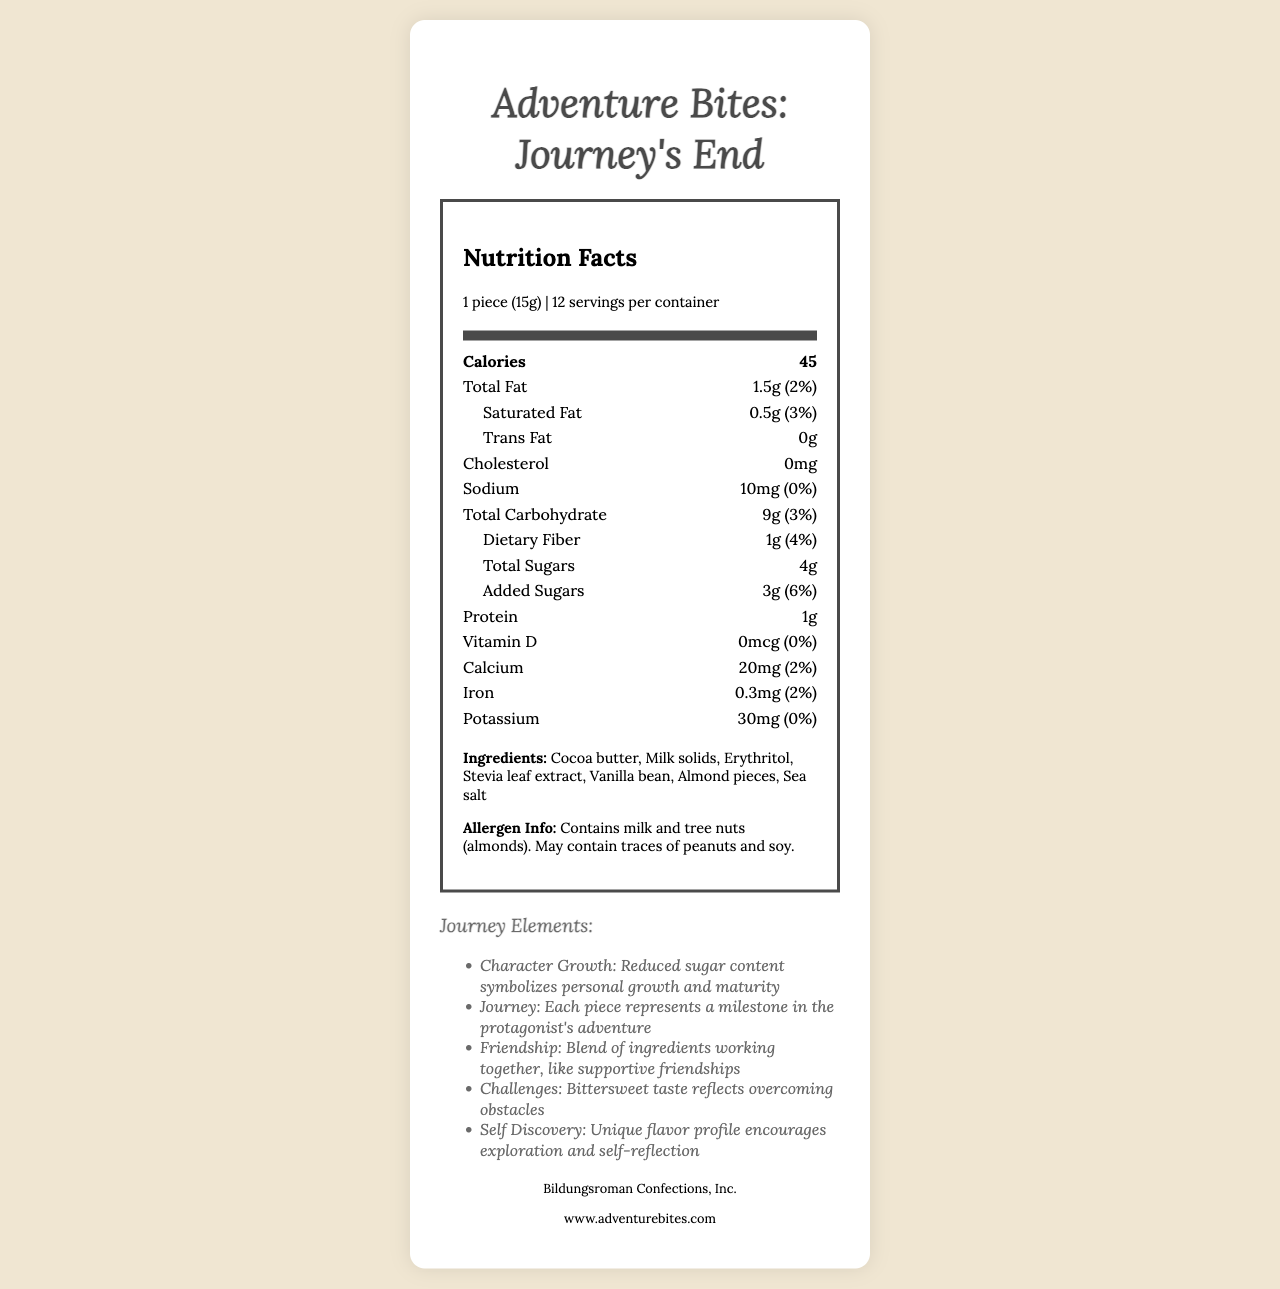what is the product name? The product name is displayed at the top of the document.
Answer: Adventure Bites: Journey's End how many calories are there per serving? The calories per serving are listed directly under "Nutrition Facts".
Answer: 45 what are the total sugars in one piece of candy? The total sugars are indicated in the "Total Sugars" section of the nutrition label.
Answer: 4g what is the amount of total fat in one serving? The amount of total fat is specified in the "Total Fat" section of the nutrition label.
Answer: 1.5g what allergens are present in the candy? This information is found in the allergen info section at the bottom of the document.
Answer: Milk and tree nuts (almonds) which nutrient has the highest daily value percentage in one serving? A. Sodium B. Saturated Fat C. Dietary Fiber D. Added Sugars Added sugars have the highest daily value percentage at 6%.
Answer: D. Added Sugars what does the reduced sugar content symbolize in the story elements? A. Friendship B. Self-discovery C. Personal growth and maturity D. Overcoming obstacles The reduced sugar content symbolizes personal growth and maturity in the story elements.
Answer: C. Personal growth and maturity is the candy high in protein? (Yes/No) The protein content is only 1g per serving, indicating it is not high in protein.
Answer: No what is the serving size for this candy? The serving size is shown under the nutrition facts header.
Answer: 1 piece (15g) what is the web address for the manufacturer? This is provided in the manufacturer info section at the bottom of the document.
Answer: www.adventurebites.com which ingredient contributes to the bittersweet taste reflecting the challenges in the story? Cocoa butter is one of the ingredients and typically contributes to a bittersweet taste, although this question involves interpretive reasoning.
Answer: Cocoa butter can you determine the price of Adventure Bites: Journey's End from the document? The document does not provide any information about the price.
Answer: Not enough information how many servings are there per container? The document states that there are 12 servings per container under the serving information.
Answer: 12 summarize the key information of the entire document. This explanation details the main points of the document including the nutrition facts, ingredients, story elements, branding, and manufacturer information.
Answer: The document provides the nutrition facts for Adventure Bites: Journey's End, a low-sugar candy. It includes serving size, calories, fat content, carbohydrate details, protein, vitamins, minerals, ingredients, and allergen info. Story elements link the reduced sugar to personal growth, each piece to an adventure milestone, and the bittersweet taste to overcoming challenges. The packaging is recyclable with quotes from classic literature. The candy is made by Bildungsroman Confections, Inc., and more information can be found on their website. 